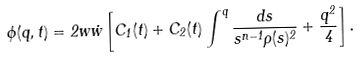<formula> <loc_0><loc_0><loc_500><loc_500>\phi ( q , t ) = 2 w \dot { w } \left [ C _ { 1 } ( t ) + C _ { 2 } ( t ) \int ^ { q } \frac { d s } { s ^ { n - 1 } \rho ( s ) ^ { 2 } } + \frac { q ^ { 2 } } { 4 } \right ] .</formula> 